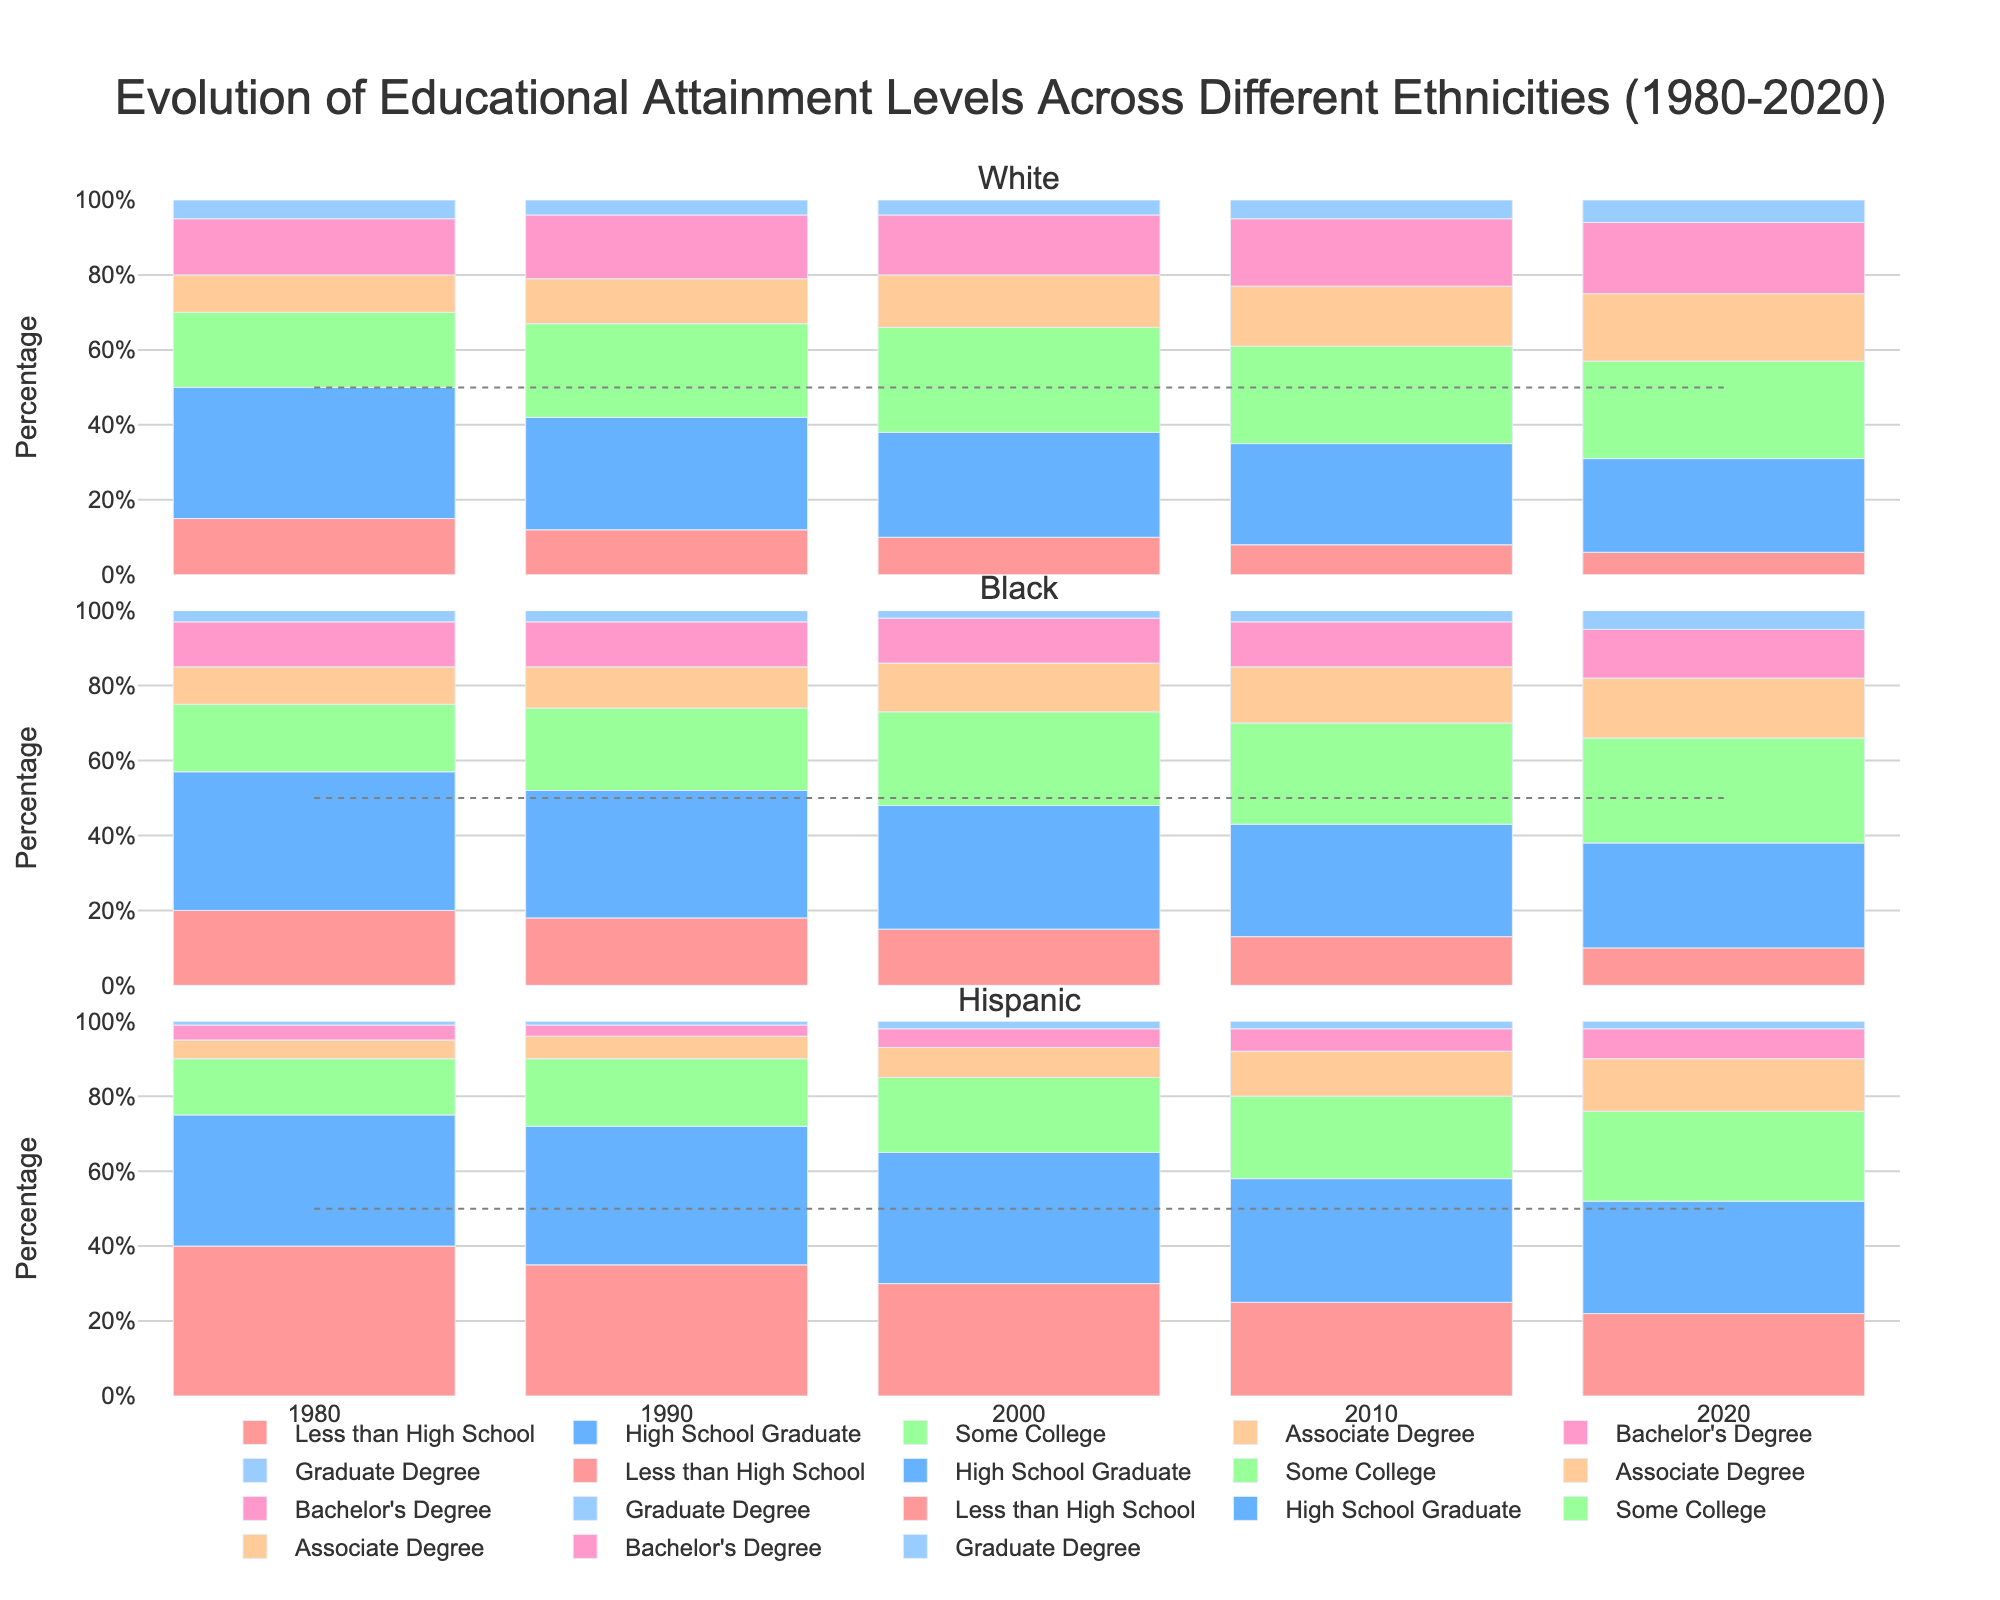What percentage of White individuals had a Bachelor's Degree in 2020? To find the percentage of White individuals with a Bachelor's Degree in 2020, look at the corresponding section of the bar for the year 2020 under the White ethnicity. The percentage is provided directly.
Answer: 19% How did the percentage of Black individuals with less than a High School education change from 1980 to 2020? Compare the heights of the "Less than High School" segments for the years 1980 and 2020 under the Black ethnicity. Subtract the 2020 value from the 1980 value to get the change.
Answer: Decreased by 10% Which ethnicity had the highest percentage of individuals with a Graduate Degree in 2010, and what was that percentage? Review the "Graduate Degree" sections of the bars for all ethnicities in the year 2010 to find the highest value.
Answer: White, 5% Across all ethnicities, which year had the lowest percentage of individuals with less than a High School education? Identify the smallest segment in the "Less than High School" category across all years and ethnicities. Verify from the bar plot.
Answer: 2020 What percentage of Hispanic individuals achieved an Associate Degree in 2000, and how does it compare to the percentage in 2020? Check the height of the "Associate Degree" segment for Hispanic ethnicity in the years 2000 and 2020. Note the percentages and then calculate the difference.
Answer: 2000: 8%, 2020: 14%, Increased by 6% What is the average percentage of White individuals with Some College education from 1980 to 2020? Sum the percentages of "Some College" for White ethnicity across the years 1980, 1990, 2000, 2010, and 2020. Then divide by 5 to find the average.
Answer: (20% + 25% + 28% + 26% + 26%) / 5 = 25% Did the percentage of Black individuals with High School Graduate level education increase or decrease from 1980 to 2010? By how much? Compare the heights of the "High School Graduate" segments for the years 1980 and 2010 under the Black ethnicity, and then calculate the difference.
Answer: Decreased by 7% For Hispanic individuals, which educational attainment level showed the most significant increase from 1980 to 2020? Review all educational categories and compare the heights of the corresponding segments between 1980 and 2020 for Hispanic ethnicity. Identify the one with the largest increase.
Answer: Some College, increased by 9% Which educational attainment level saw the least change for White individuals between 1990 and 2010? Compare the heights of all segments for the White ethnicity between 1990 and 2010. Identify the segment with the smallest change in height.
Answer: Graduate Degree, increased by 1% In 1990, what is the combined percentage of Black individuals with an Associate Degree or higher educational attainment? Sum the percentages of "Associate Degree", "Bachelor's Degree", and "Graduate Degree" for Black ethnicity in the year 1990.
Answer: 20% 